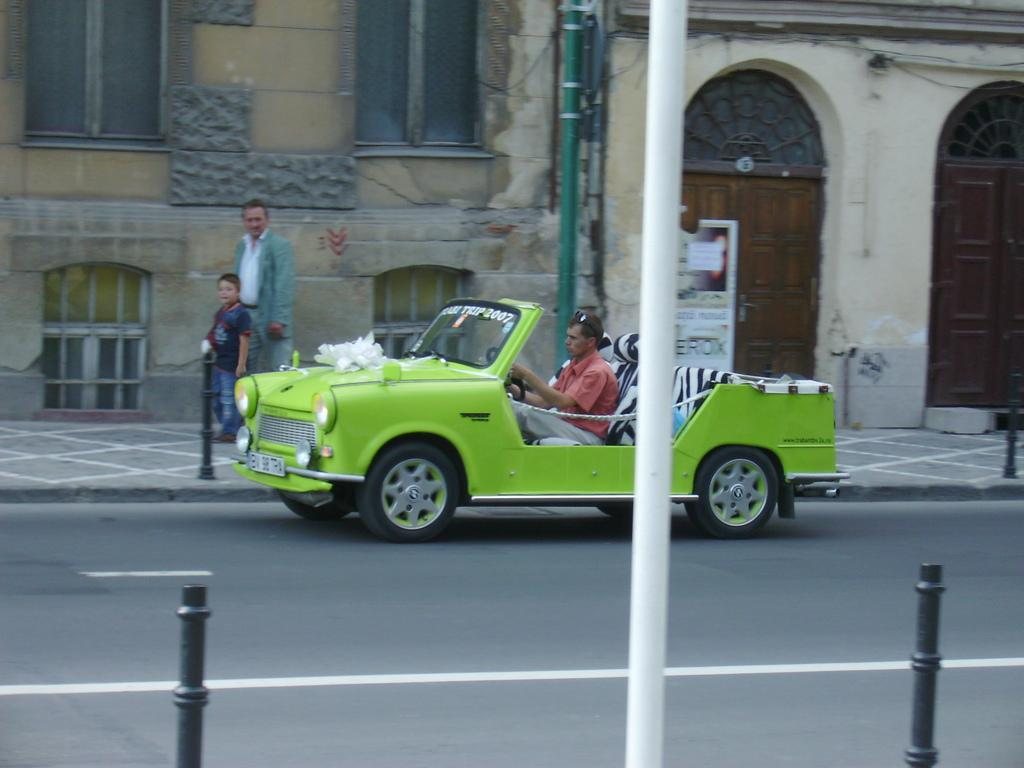What is the person in the image doing? The person in the image is driving a car. Where is the car located in the image? The car is on the road. What else can be seen on the road in the image? There is a child and a person walking on the pavement beside the road. What can be seen in the background of the image? There is a building visible in the background of the image. What type of tray is being used by the dad in the image? There is no dad or tray present in the image. 